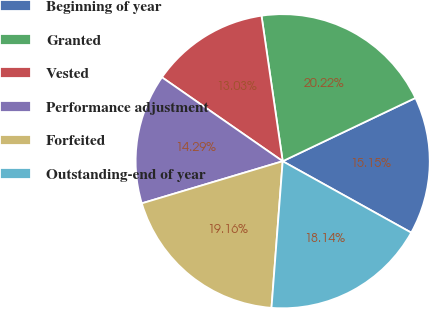Convert chart to OTSL. <chart><loc_0><loc_0><loc_500><loc_500><pie_chart><fcel>Beginning of year<fcel>Granted<fcel>Vested<fcel>Performance adjustment<fcel>Forfeited<fcel>Outstanding-end of year<nl><fcel>15.15%<fcel>20.22%<fcel>13.03%<fcel>14.29%<fcel>19.16%<fcel>18.14%<nl></chart> 